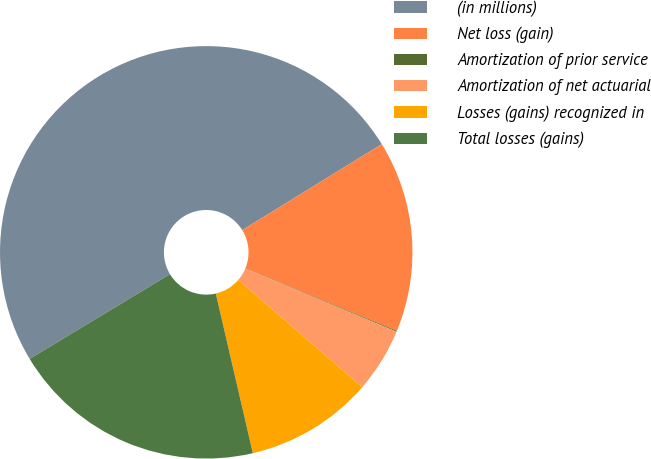Convert chart to OTSL. <chart><loc_0><loc_0><loc_500><loc_500><pie_chart><fcel>(in millions)<fcel>Net loss (gain)<fcel>Amortization of prior service<fcel>Amortization of net actuarial<fcel>Losses (gains) recognized in<fcel>Total losses (gains)<nl><fcel>49.85%<fcel>15.01%<fcel>0.07%<fcel>5.05%<fcel>10.03%<fcel>19.99%<nl></chart> 